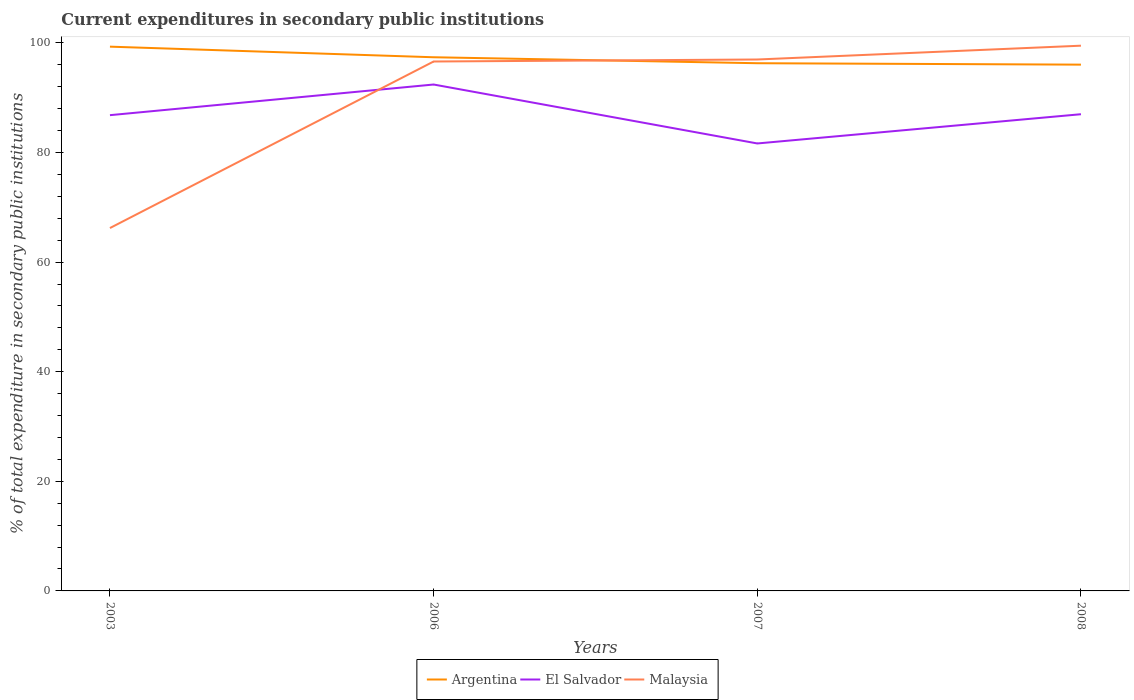How many different coloured lines are there?
Give a very brief answer. 3. Across all years, what is the maximum current expenditures in secondary public institutions in Malaysia?
Offer a terse response. 66.21. What is the total current expenditures in secondary public institutions in El Salvador in the graph?
Offer a terse response. -0.17. What is the difference between the highest and the second highest current expenditures in secondary public institutions in El Salvador?
Ensure brevity in your answer.  10.75. Is the current expenditures in secondary public institutions in Argentina strictly greater than the current expenditures in secondary public institutions in Malaysia over the years?
Ensure brevity in your answer.  No. How many lines are there?
Give a very brief answer. 3. What is the difference between two consecutive major ticks on the Y-axis?
Provide a short and direct response. 20. Are the values on the major ticks of Y-axis written in scientific E-notation?
Your answer should be compact. No. Does the graph contain grids?
Offer a terse response. No. Where does the legend appear in the graph?
Provide a short and direct response. Bottom center. How many legend labels are there?
Your answer should be compact. 3. How are the legend labels stacked?
Provide a succinct answer. Horizontal. What is the title of the graph?
Ensure brevity in your answer.  Current expenditures in secondary public institutions. What is the label or title of the X-axis?
Provide a succinct answer. Years. What is the label or title of the Y-axis?
Offer a very short reply. % of total expenditure in secondary public institutions. What is the % of total expenditure in secondary public institutions of Argentina in 2003?
Give a very brief answer. 99.31. What is the % of total expenditure in secondary public institutions in El Salvador in 2003?
Offer a very short reply. 86.81. What is the % of total expenditure in secondary public institutions of Malaysia in 2003?
Make the answer very short. 66.21. What is the % of total expenditure in secondary public institutions in Argentina in 2006?
Provide a short and direct response. 97.38. What is the % of total expenditure in secondary public institutions of El Salvador in 2006?
Offer a very short reply. 92.4. What is the % of total expenditure in secondary public institutions of Malaysia in 2006?
Your answer should be very brief. 96.61. What is the % of total expenditure in secondary public institutions of Argentina in 2007?
Provide a succinct answer. 96.29. What is the % of total expenditure in secondary public institutions in El Salvador in 2007?
Your response must be concise. 81.65. What is the % of total expenditure in secondary public institutions in Malaysia in 2007?
Keep it short and to the point. 96.97. What is the % of total expenditure in secondary public institutions of Argentina in 2008?
Provide a short and direct response. 96.03. What is the % of total expenditure in secondary public institutions in El Salvador in 2008?
Your answer should be very brief. 86.98. What is the % of total expenditure in secondary public institutions of Malaysia in 2008?
Provide a succinct answer. 99.49. Across all years, what is the maximum % of total expenditure in secondary public institutions in Argentina?
Provide a short and direct response. 99.31. Across all years, what is the maximum % of total expenditure in secondary public institutions in El Salvador?
Offer a terse response. 92.4. Across all years, what is the maximum % of total expenditure in secondary public institutions in Malaysia?
Give a very brief answer. 99.49. Across all years, what is the minimum % of total expenditure in secondary public institutions of Argentina?
Provide a short and direct response. 96.03. Across all years, what is the minimum % of total expenditure in secondary public institutions in El Salvador?
Make the answer very short. 81.65. Across all years, what is the minimum % of total expenditure in secondary public institutions of Malaysia?
Ensure brevity in your answer.  66.21. What is the total % of total expenditure in secondary public institutions of Argentina in the graph?
Keep it short and to the point. 389.01. What is the total % of total expenditure in secondary public institutions in El Salvador in the graph?
Provide a succinct answer. 347.85. What is the total % of total expenditure in secondary public institutions in Malaysia in the graph?
Offer a terse response. 359.28. What is the difference between the % of total expenditure in secondary public institutions in Argentina in 2003 and that in 2006?
Your response must be concise. 1.93. What is the difference between the % of total expenditure in secondary public institutions of El Salvador in 2003 and that in 2006?
Provide a succinct answer. -5.59. What is the difference between the % of total expenditure in secondary public institutions of Malaysia in 2003 and that in 2006?
Provide a succinct answer. -30.39. What is the difference between the % of total expenditure in secondary public institutions in Argentina in 2003 and that in 2007?
Keep it short and to the point. 3.02. What is the difference between the % of total expenditure in secondary public institutions in El Salvador in 2003 and that in 2007?
Provide a short and direct response. 5.16. What is the difference between the % of total expenditure in secondary public institutions in Malaysia in 2003 and that in 2007?
Give a very brief answer. -30.76. What is the difference between the % of total expenditure in secondary public institutions of Argentina in 2003 and that in 2008?
Make the answer very short. 3.28. What is the difference between the % of total expenditure in secondary public institutions of El Salvador in 2003 and that in 2008?
Your response must be concise. -0.17. What is the difference between the % of total expenditure in secondary public institutions in Malaysia in 2003 and that in 2008?
Provide a succinct answer. -33.28. What is the difference between the % of total expenditure in secondary public institutions of Argentina in 2006 and that in 2007?
Make the answer very short. 1.09. What is the difference between the % of total expenditure in secondary public institutions in El Salvador in 2006 and that in 2007?
Offer a terse response. 10.76. What is the difference between the % of total expenditure in secondary public institutions in Malaysia in 2006 and that in 2007?
Offer a terse response. -0.36. What is the difference between the % of total expenditure in secondary public institutions in Argentina in 2006 and that in 2008?
Provide a short and direct response. 1.35. What is the difference between the % of total expenditure in secondary public institutions of El Salvador in 2006 and that in 2008?
Keep it short and to the point. 5.42. What is the difference between the % of total expenditure in secondary public institutions of Malaysia in 2006 and that in 2008?
Your answer should be compact. -2.88. What is the difference between the % of total expenditure in secondary public institutions of Argentina in 2007 and that in 2008?
Offer a very short reply. 0.26. What is the difference between the % of total expenditure in secondary public institutions in El Salvador in 2007 and that in 2008?
Make the answer very short. -5.34. What is the difference between the % of total expenditure in secondary public institutions in Malaysia in 2007 and that in 2008?
Make the answer very short. -2.52. What is the difference between the % of total expenditure in secondary public institutions in Argentina in 2003 and the % of total expenditure in secondary public institutions in El Salvador in 2006?
Your answer should be compact. 6.91. What is the difference between the % of total expenditure in secondary public institutions in Argentina in 2003 and the % of total expenditure in secondary public institutions in Malaysia in 2006?
Your answer should be compact. 2.71. What is the difference between the % of total expenditure in secondary public institutions in El Salvador in 2003 and the % of total expenditure in secondary public institutions in Malaysia in 2006?
Provide a succinct answer. -9.79. What is the difference between the % of total expenditure in secondary public institutions of Argentina in 2003 and the % of total expenditure in secondary public institutions of El Salvador in 2007?
Offer a very short reply. 17.66. What is the difference between the % of total expenditure in secondary public institutions in Argentina in 2003 and the % of total expenditure in secondary public institutions in Malaysia in 2007?
Your answer should be very brief. 2.34. What is the difference between the % of total expenditure in secondary public institutions of El Salvador in 2003 and the % of total expenditure in secondary public institutions of Malaysia in 2007?
Provide a short and direct response. -10.16. What is the difference between the % of total expenditure in secondary public institutions in Argentina in 2003 and the % of total expenditure in secondary public institutions in El Salvador in 2008?
Make the answer very short. 12.33. What is the difference between the % of total expenditure in secondary public institutions of Argentina in 2003 and the % of total expenditure in secondary public institutions of Malaysia in 2008?
Offer a terse response. -0.18. What is the difference between the % of total expenditure in secondary public institutions of El Salvador in 2003 and the % of total expenditure in secondary public institutions of Malaysia in 2008?
Make the answer very short. -12.68. What is the difference between the % of total expenditure in secondary public institutions in Argentina in 2006 and the % of total expenditure in secondary public institutions in El Salvador in 2007?
Your response must be concise. 15.73. What is the difference between the % of total expenditure in secondary public institutions in Argentina in 2006 and the % of total expenditure in secondary public institutions in Malaysia in 2007?
Keep it short and to the point. 0.41. What is the difference between the % of total expenditure in secondary public institutions of El Salvador in 2006 and the % of total expenditure in secondary public institutions of Malaysia in 2007?
Give a very brief answer. -4.56. What is the difference between the % of total expenditure in secondary public institutions of Argentina in 2006 and the % of total expenditure in secondary public institutions of El Salvador in 2008?
Provide a short and direct response. 10.39. What is the difference between the % of total expenditure in secondary public institutions of Argentina in 2006 and the % of total expenditure in secondary public institutions of Malaysia in 2008?
Ensure brevity in your answer.  -2.11. What is the difference between the % of total expenditure in secondary public institutions of El Salvador in 2006 and the % of total expenditure in secondary public institutions of Malaysia in 2008?
Offer a terse response. -7.08. What is the difference between the % of total expenditure in secondary public institutions of Argentina in 2007 and the % of total expenditure in secondary public institutions of El Salvador in 2008?
Give a very brief answer. 9.31. What is the difference between the % of total expenditure in secondary public institutions in Argentina in 2007 and the % of total expenditure in secondary public institutions in Malaysia in 2008?
Your answer should be very brief. -3.2. What is the difference between the % of total expenditure in secondary public institutions in El Salvador in 2007 and the % of total expenditure in secondary public institutions in Malaysia in 2008?
Offer a very short reply. -17.84. What is the average % of total expenditure in secondary public institutions in Argentina per year?
Offer a very short reply. 97.25. What is the average % of total expenditure in secondary public institutions of El Salvador per year?
Your answer should be compact. 86.96. What is the average % of total expenditure in secondary public institutions of Malaysia per year?
Offer a very short reply. 89.82. In the year 2003, what is the difference between the % of total expenditure in secondary public institutions of Argentina and % of total expenditure in secondary public institutions of El Salvador?
Give a very brief answer. 12.5. In the year 2003, what is the difference between the % of total expenditure in secondary public institutions in Argentina and % of total expenditure in secondary public institutions in Malaysia?
Provide a succinct answer. 33.1. In the year 2003, what is the difference between the % of total expenditure in secondary public institutions in El Salvador and % of total expenditure in secondary public institutions in Malaysia?
Provide a succinct answer. 20.6. In the year 2006, what is the difference between the % of total expenditure in secondary public institutions in Argentina and % of total expenditure in secondary public institutions in El Salvador?
Provide a succinct answer. 4.97. In the year 2006, what is the difference between the % of total expenditure in secondary public institutions in Argentina and % of total expenditure in secondary public institutions in Malaysia?
Provide a succinct answer. 0.77. In the year 2006, what is the difference between the % of total expenditure in secondary public institutions of El Salvador and % of total expenditure in secondary public institutions of Malaysia?
Your response must be concise. -4.2. In the year 2007, what is the difference between the % of total expenditure in secondary public institutions of Argentina and % of total expenditure in secondary public institutions of El Salvador?
Offer a terse response. 14.64. In the year 2007, what is the difference between the % of total expenditure in secondary public institutions in Argentina and % of total expenditure in secondary public institutions in Malaysia?
Offer a very short reply. -0.68. In the year 2007, what is the difference between the % of total expenditure in secondary public institutions of El Salvador and % of total expenditure in secondary public institutions of Malaysia?
Offer a terse response. -15.32. In the year 2008, what is the difference between the % of total expenditure in secondary public institutions of Argentina and % of total expenditure in secondary public institutions of El Salvador?
Offer a very short reply. 9.05. In the year 2008, what is the difference between the % of total expenditure in secondary public institutions of Argentina and % of total expenditure in secondary public institutions of Malaysia?
Make the answer very short. -3.46. In the year 2008, what is the difference between the % of total expenditure in secondary public institutions in El Salvador and % of total expenditure in secondary public institutions in Malaysia?
Your answer should be compact. -12.5. What is the ratio of the % of total expenditure in secondary public institutions of Argentina in 2003 to that in 2006?
Give a very brief answer. 1.02. What is the ratio of the % of total expenditure in secondary public institutions of El Salvador in 2003 to that in 2006?
Ensure brevity in your answer.  0.94. What is the ratio of the % of total expenditure in secondary public institutions of Malaysia in 2003 to that in 2006?
Your answer should be very brief. 0.69. What is the ratio of the % of total expenditure in secondary public institutions of Argentina in 2003 to that in 2007?
Offer a very short reply. 1.03. What is the ratio of the % of total expenditure in secondary public institutions of El Salvador in 2003 to that in 2007?
Your answer should be very brief. 1.06. What is the ratio of the % of total expenditure in secondary public institutions of Malaysia in 2003 to that in 2007?
Provide a short and direct response. 0.68. What is the ratio of the % of total expenditure in secondary public institutions of Argentina in 2003 to that in 2008?
Ensure brevity in your answer.  1.03. What is the ratio of the % of total expenditure in secondary public institutions in Malaysia in 2003 to that in 2008?
Your answer should be very brief. 0.67. What is the ratio of the % of total expenditure in secondary public institutions of Argentina in 2006 to that in 2007?
Your response must be concise. 1.01. What is the ratio of the % of total expenditure in secondary public institutions in El Salvador in 2006 to that in 2007?
Provide a succinct answer. 1.13. What is the ratio of the % of total expenditure in secondary public institutions in Argentina in 2006 to that in 2008?
Your answer should be very brief. 1.01. What is the ratio of the % of total expenditure in secondary public institutions of El Salvador in 2006 to that in 2008?
Offer a very short reply. 1.06. What is the ratio of the % of total expenditure in secondary public institutions of Malaysia in 2006 to that in 2008?
Your answer should be very brief. 0.97. What is the ratio of the % of total expenditure in secondary public institutions of El Salvador in 2007 to that in 2008?
Provide a succinct answer. 0.94. What is the ratio of the % of total expenditure in secondary public institutions of Malaysia in 2007 to that in 2008?
Ensure brevity in your answer.  0.97. What is the difference between the highest and the second highest % of total expenditure in secondary public institutions of Argentina?
Provide a succinct answer. 1.93. What is the difference between the highest and the second highest % of total expenditure in secondary public institutions of El Salvador?
Offer a terse response. 5.42. What is the difference between the highest and the second highest % of total expenditure in secondary public institutions of Malaysia?
Your response must be concise. 2.52. What is the difference between the highest and the lowest % of total expenditure in secondary public institutions in Argentina?
Make the answer very short. 3.28. What is the difference between the highest and the lowest % of total expenditure in secondary public institutions in El Salvador?
Make the answer very short. 10.76. What is the difference between the highest and the lowest % of total expenditure in secondary public institutions of Malaysia?
Your response must be concise. 33.28. 